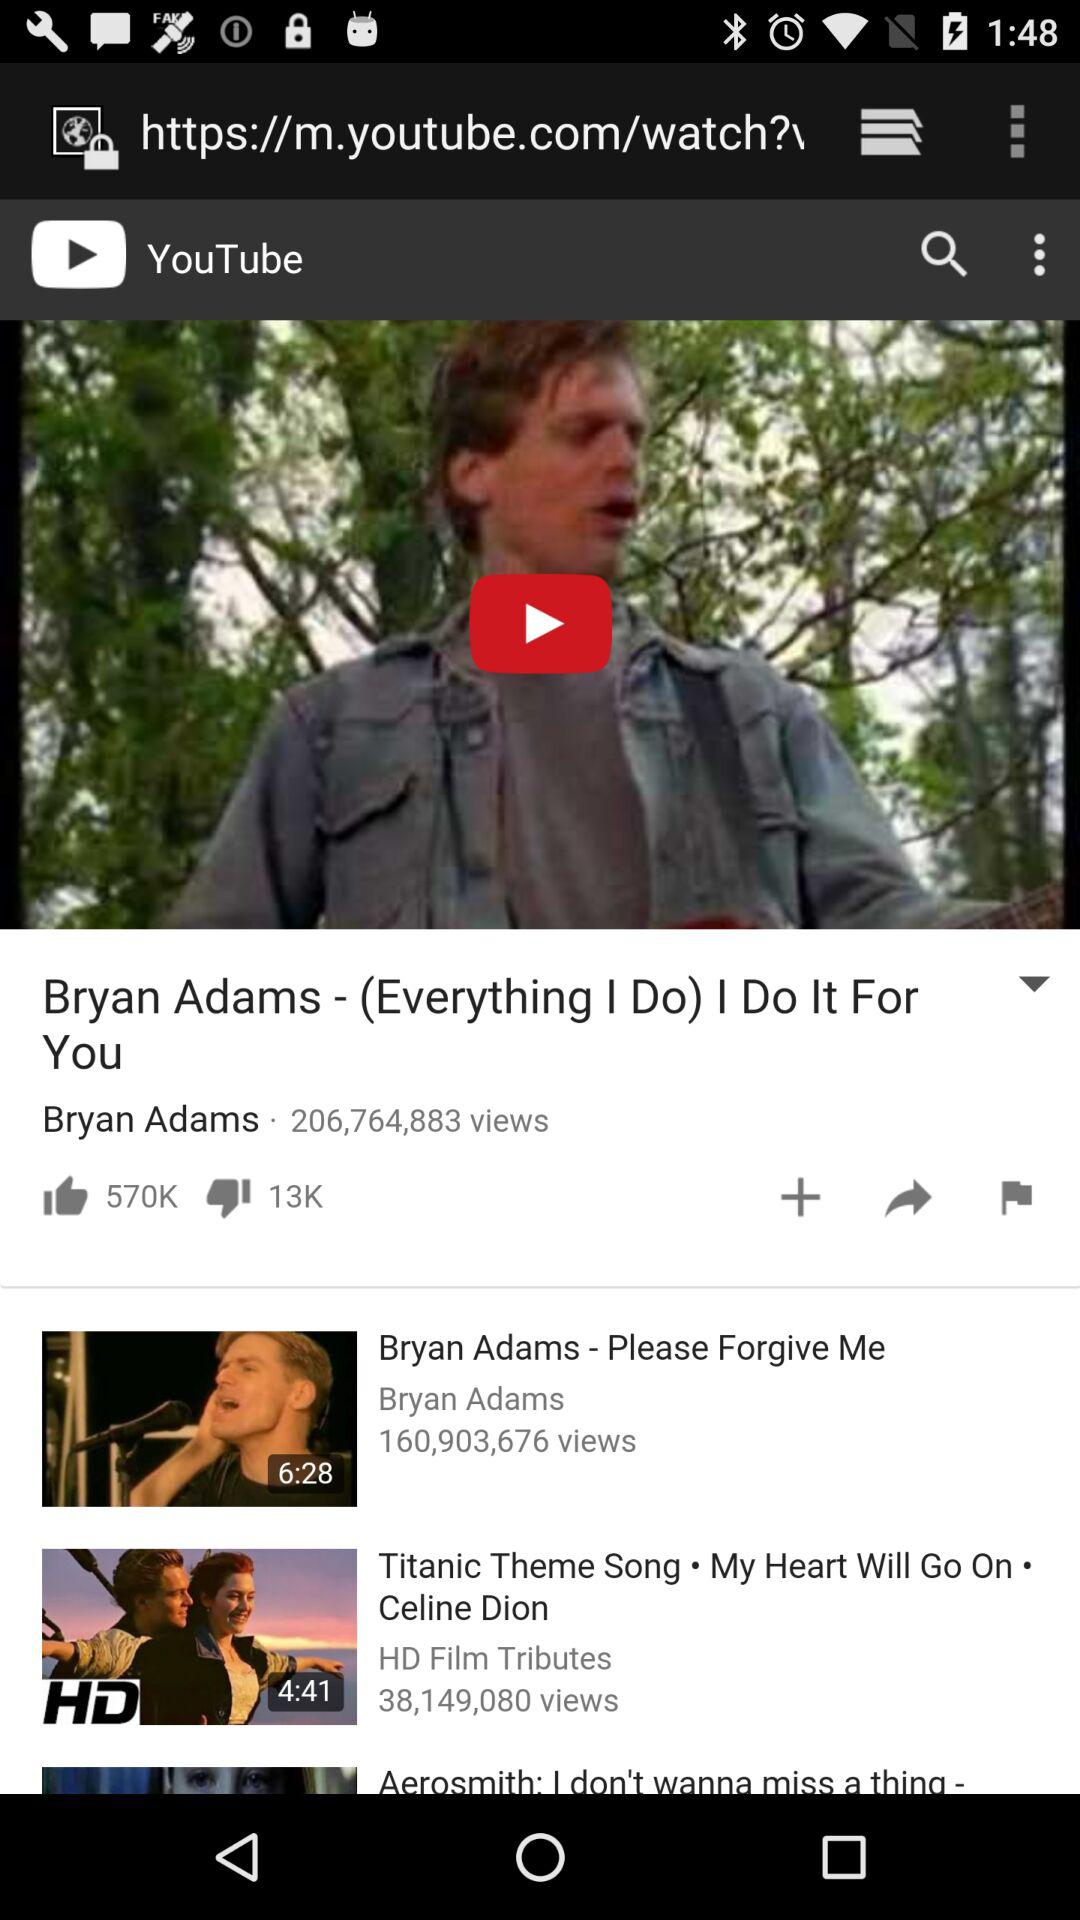How many people have viewed the "Bryan Adams - (Everything I Do) I Do It For You" video? The video was viewed by 206,764,883 people. 